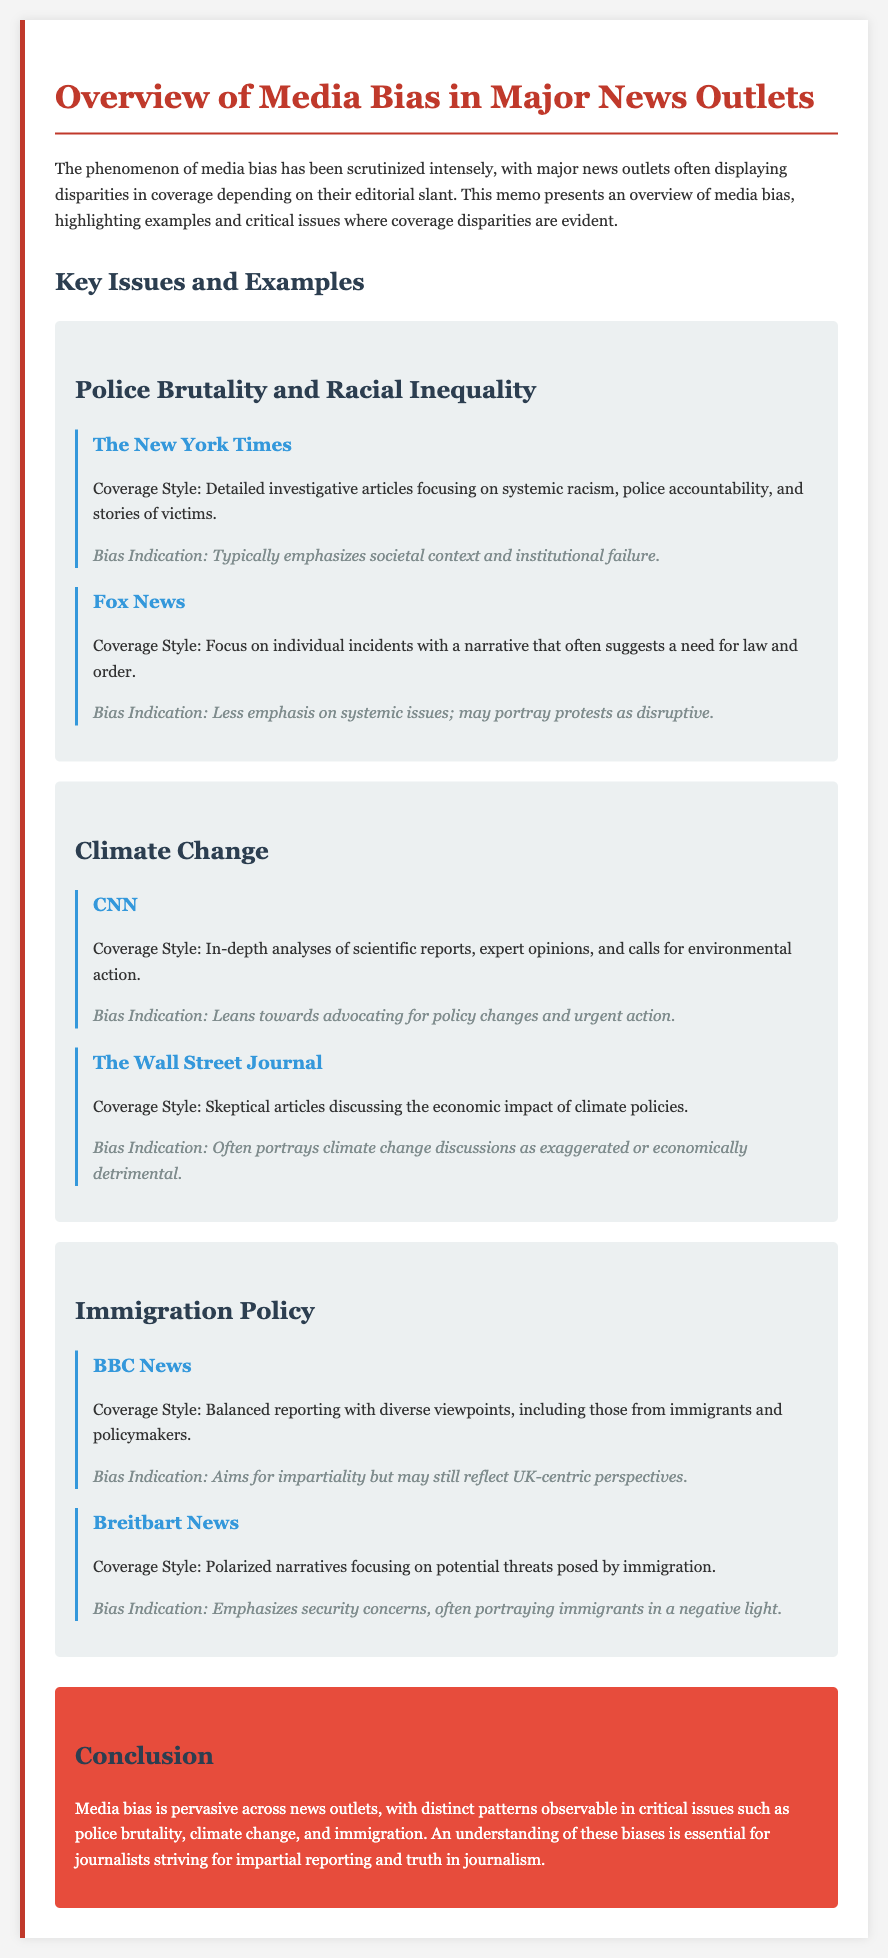What is the main topic of the memo? The memo discusses media bias in major news outlets and highlights coverage disparities on critical issues.
Answer: Media bias Which issue is associated with The New York Times coverage? The New York Times' coverage focuses on systemic racism and police accountability in the context of police brutality.
Answer: Police brutality What is the bias indication for Fox News regarding police brutality? Fox News tends to portray protests as disruptive rather than focusing on systemic issues.
Answer: Less emphasis on systemic issues How does CNN's coverage of climate change differ from The Wall Street Journal's? CNN advocates for urgent environmental policy changes, while The Wall Street Journal is skeptical about climate discussions' economic impact.
Answer: Advocating for policy changes What approach does BBC News take toward immigration policy coverage? BBC News aims for balanced reporting with diverse viewpoints, including those from immigrants and policymakers.
Answer: Balanced reporting What is the conclusion drawn about media bias in the memo? The memo concludes that media bias is pervasive across news outlets, emphasizing the importance of understanding these biases for impartial reporting.
Answer: Media bias is pervasive Which outlet focuses on potential threats posed by immigration? Breitbart News focuses on potential threats concerning immigration in its narratives.
Answer: Breitbart News 